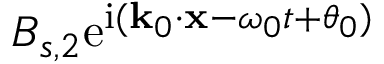<formula> <loc_0><loc_0><loc_500><loc_500>B _ { s , 2 } e ^ { i ( k _ { 0 } \cdot x - \omega _ { 0 } t + \theta _ { 0 } ) }</formula> 